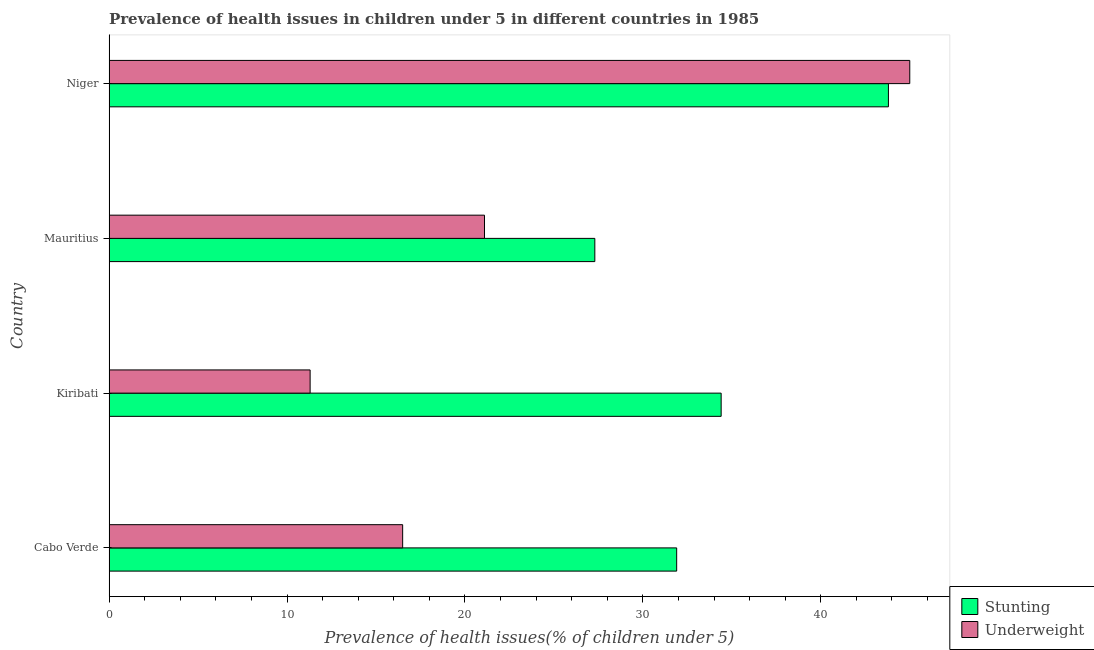How many different coloured bars are there?
Provide a short and direct response. 2. Are the number of bars per tick equal to the number of legend labels?
Make the answer very short. Yes. Are the number of bars on each tick of the Y-axis equal?
Give a very brief answer. Yes. What is the label of the 4th group of bars from the top?
Provide a short and direct response. Cabo Verde. What is the percentage of stunted children in Mauritius?
Your answer should be very brief. 27.3. Across all countries, what is the maximum percentage of stunted children?
Keep it short and to the point. 43.8. Across all countries, what is the minimum percentage of underweight children?
Ensure brevity in your answer.  11.3. In which country was the percentage of stunted children maximum?
Give a very brief answer. Niger. In which country was the percentage of stunted children minimum?
Offer a terse response. Mauritius. What is the total percentage of underweight children in the graph?
Offer a very short reply. 93.9. What is the difference between the percentage of underweight children in Kiribati and the percentage of stunted children in Cabo Verde?
Keep it short and to the point. -20.6. What is the average percentage of stunted children per country?
Offer a terse response. 34.35. What is the difference between the percentage of underweight children and percentage of stunted children in Niger?
Ensure brevity in your answer.  1.2. What is the ratio of the percentage of underweight children in Cabo Verde to that in Mauritius?
Offer a terse response. 0.78. Is the percentage of stunted children in Cabo Verde less than that in Niger?
Your response must be concise. Yes. What is the difference between the highest and the lowest percentage of underweight children?
Keep it short and to the point. 33.7. In how many countries, is the percentage of stunted children greater than the average percentage of stunted children taken over all countries?
Your answer should be very brief. 2. What does the 2nd bar from the top in Kiribati represents?
Ensure brevity in your answer.  Stunting. What does the 1st bar from the bottom in Kiribati represents?
Your response must be concise. Stunting. Are the values on the major ticks of X-axis written in scientific E-notation?
Provide a short and direct response. No. Does the graph contain grids?
Offer a terse response. No. How many legend labels are there?
Ensure brevity in your answer.  2. How are the legend labels stacked?
Provide a short and direct response. Vertical. What is the title of the graph?
Keep it short and to the point. Prevalence of health issues in children under 5 in different countries in 1985. Does "Non-residents" appear as one of the legend labels in the graph?
Give a very brief answer. No. What is the label or title of the X-axis?
Offer a very short reply. Prevalence of health issues(% of children under 5). What is the Prevalence of health issues(% of children under 5) of Stunting in Cabo Verde?
Keep it short and to the point. 31.9. What is the Prevalence of health issues(% of children under 5) of Stunting in Kiribati?
Provide a succinct answer. 34.4. What is the Prevalence of health issues(% of children under 5) in Underweight in Kiribati?
Give a very brief answer. 11.3. What is the Prevalence of health issues(% of children under 5) in Stunting in Mauritius?
Your answer should be very brief. 27.3. What is the Prevalence of health issues(% of children under 5) in Underweight in Mauritius?
Keep it short and to the point. 21.1. What is the Prevalence of health issues(% of children under 5) of Stunting in Niger?
Your answer should be compact. 43.8. Across all countries, what is the maximum Prevalence of health issues(% of children under 5) in Stunting?
Offer a very short reply. 43.8. Across all countries, what is the maximum Prevalence of health issues(% of children under 5) in Underweight?
Keep it short and to the point. 45. Across all countries, what is the minimum Prevalence of health issues(% of children under 5) of Stunting?
Your answer should be compact. 27.3. Across all countries, what is the minimum Prevalence of health issues(% of children under 5) of Underweight?
Give a very brief answer. 11.3. What is the total Prevalence of health issues(% of children under 5) of Stunting in the graph?
Provide a succinct answer. 137.4. What is the total Prevalence of health issues(% of children under 5) of Underweight in the graph?
Your answer should be very brief. 93.9. What is the difference between the Prevalence of health issues(% of children under 5) of Underweight in Cabo Verde and that in Kiribati?
Offer a terse response. 5.2. What is the difference between the Prevalence of health issues(% of children under 5) in Stunting in Cabo Verde and that in Niger?
Ensure brevity in your answer.  -11.9. What is the difference between the Prevalence of health issues(% of children under 5) in Underweight in Cabo Verde and that in Niger?
Offer a very short reply. -28.5. What is the difference between the Prevalence of health issues(% of children under 5) in Underweight in Kiribati and that in Niger?
Ensure brevity in your answer.  -33.7. What is the difference between the Prevalence of health issues(% of children under 5) in Stunting in Mauritius and that in Niger?
Give a very brief answer. -16.5. What is the difference between the Prevalence of health issues(% of children under 5) of Underweight in Mauritius and that in Niger?
Keep it short and to the point. -23.9. What is the difference between the Prevalence of health issues(% of children under 5) in Stunting in Cabo Verde and the Prevalence of health issues(% of children under 5) in Underweight in Kiribati?
Offer a very short reply. 20.6. What is the difference between the Prevalence of health issues(% of children under 5) of Stunting in Mauritius and the Prevalence of health issues(% of children under 5) of Underweight in Niger?
Keep it short and to the point. -17.7. What is the average Prevalence of health issues(% of children under 5) in Stunting per country?
Your answer should be compact. 34.35. What is the average Prevalence of health issues(% of children under 5) in Underweight per country?
Make the answer very short. 23.48. What is the difference between the Prevalence of health issues(% of children under 5) in Stunting and Prevalence of health issues(% of children under 5) in Underweight in Cabo Verde?
Provide a succinct answer. 15.4. What is the difference between the Prevalence of health issues(% of children under 5) in Stunting and Prevalence of health issues(% of children under 5) in Underweight in Kiribati?
Give a very brief answer. 23.1. What is the difference between the Prevalence of health issues(% of children under 5) of Stunting and Prevalence of health issues(% of children under 5) of Underweight in Niger?
Offer a very short reply. -1.2. What is the ratio of the Prevalence of health issues(% of children under 5) in Stunting in Cabo Verde to that in Kiribati?
Give a very brief answer. 0.93. What is the ratio of the Prevalence of health issues(% of children under 5) of Underweight in Cabo Verde to that in Kiribati?
Give a very brief answer. 1.46. What is the ratio of the Prevalence of health issues(% of children under 5) in Stunting in Cabo Verde to that in Mauritius?
Provide a succinct answer. 1.17. What is the ratio of the Prevalence of health issues(% of children under 5) of Underweight in Cabo Verde to that in Mauritius?
Provide a succinct answer. 0.78. What is the ratio of the Prevalence of health issues(% of children under 5) of Stunting in Cabo Verde to that in Niger?
Offer a terse response. 0.73. What is the ratio of the Prevalence of health issues(% of children under 5) of Underweight in Cabo Verde to that in Niger?
Offer a terse response. 0.37. What is the ratio of the Prevalence of health issues(% of children under 5) of Stunting in Kiribati to that in Mauritius?
Give a very brief answer. 1.26. What is the ratio of the Prevalence of health issues(% of children under 5) of Underweight in Kiribati to that in Mauritius?
Ensure brevity in your answer.  0.54. What is the ratio of the Prevalence of health issues(% of children under 5) of Stunting in Kiribati to that in Niger?
Give a very brief answer. 0.79. What is the ratio of the Prevalence of health issues(% of children under 5) in Underweight in Kiribati to that in Niger?
Keep it short and to the point. 0.25. What is the ratio of the Prevalence of health issues(% of children under 5) of Stunting in Mauritius to that in Niger?
Your answer should be very brief. 0.62. What is the ratio of the Prevalence of health issues(% of children under 5) in Underweight in Mauritius to that in Niger?
Provide a succinct answer. 0.47. What is the difference between the highest and the second highest Prevalence of health issues(% of children under 5) of Stunting?
Your answer should be very brief. 9.4. What is the difference between the highest and the second highest Prevalence of health issues(% of children under 5) in Underweight?
Offer a terse response. 23.9. What is the difference between the highest and the lowest Prevalence of health issues(% of children under 5) of Stunting?
Provide a succinct answer. 16.5. What is the difference between the highest and the lowest Prevalence of health issues(% of children under 5) in Underweight?
Provide a short and direct response. 33.7. 